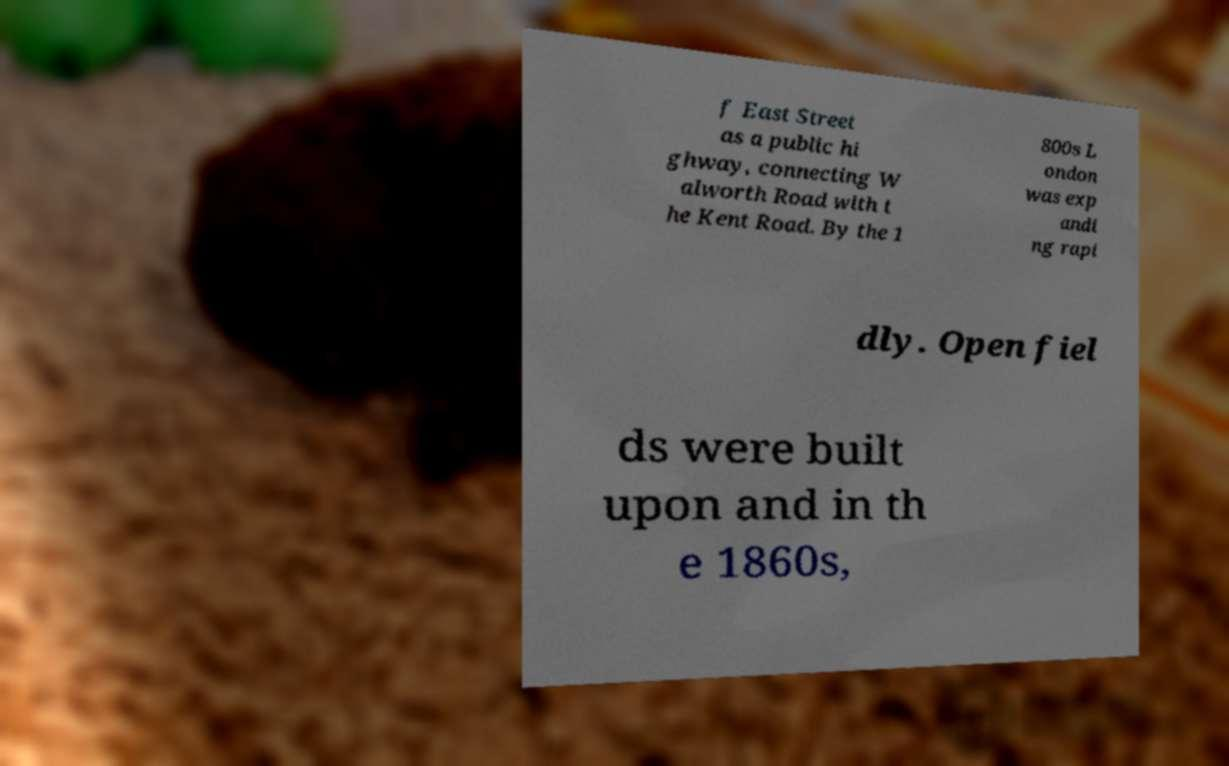For documentation purposes, I need the text within this image transcribed. Could you provide that? f East Street as a public hi ghway, connecting W alworth Road with t he Kent Road. By the 1 800s L ondon was exp andi ng rapi dly. Open fiel ds were built upon and in th e 1860s, 